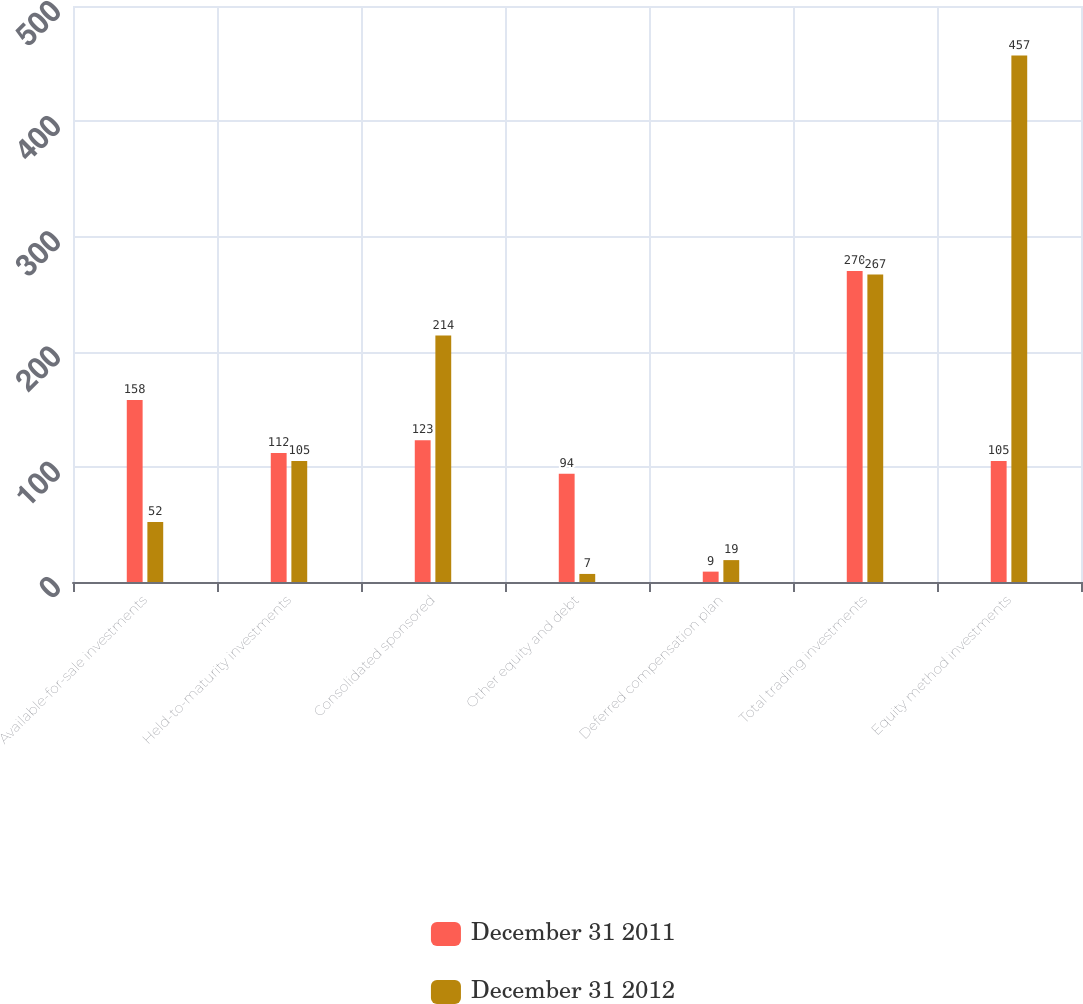Convert chart. <chart><loc_0><loc_0><loc_500><loc_500><stacked_bar_chart><ecel><fcel>Available-for-sale investments<fcel>Held-to-maturity investments<fcel>Consolidated sponsored<fcel>Other equity and debt<fcel>Deferred compensation plan<fcel>Total trading investments<fcel>Equity method investments<nl><fcel>December 31 2011<fcel>158<fcel>112<fcel>123<fcel>94<fcel>9<fcel>270<fcel>105<nl><fcel>December 31 2012<fcel>52<fcel>105<fcel>214<fcel>7<fcel>19<fcel>267<fcel>457<nl></chart> 